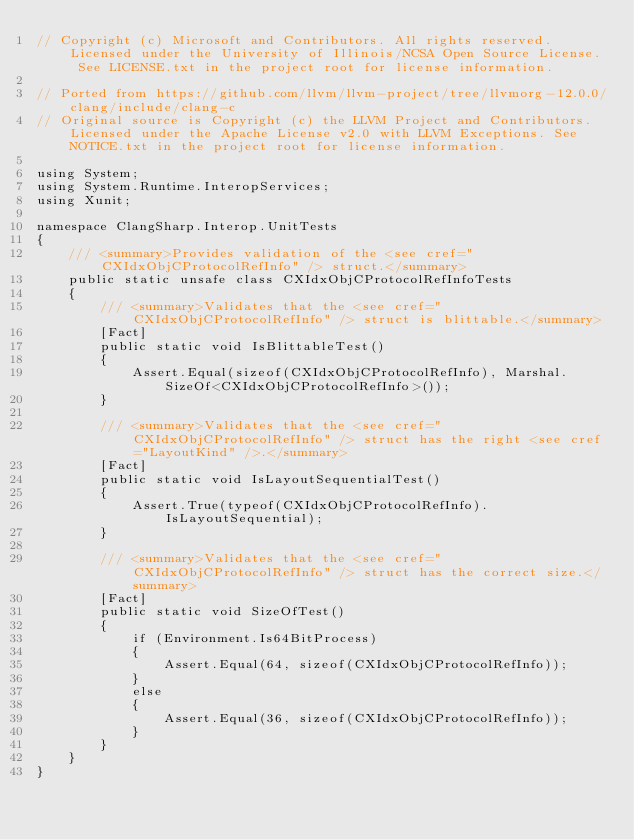<code> <loc_0><loc_0><loc_500><loc_500><_C#_>// Copyright (c) Microsoft and Contributors. All rights reserved. Licensed under the University of Illinois/NCSA Open Source License. See LICENSE.txt in the project root for license information.

// Ported from https://github.com/llvm/llvm-project/tree/llvmorg-12.0.0/clang/include/clang-c
// Original source is Copyright (c) the LLVM Project and Contributors. Licensed under the Apache License v2.0 with LLVM Exceptions. See NOTICE.txt in the project root for license information.

using System;
using System.Runtime.InteropServices;
using Xunit;

namespace ClangSharp.Interop.UnitTests
{
    /// <summary>Provides validation of the <see cref="CXIdxObjCProtocolRefInfo" /> struct.</summary>
    public static unsafe class CXIdxObjCProtocolRefInfoTests
    {
        /// <summary>Validates that the <see cref="CXIdxObjCProtocolRefInfo" /> struct is blittable.</summary>
        [Fact]
        public static void IsBlittableTest()
        {
            Assert.Equal(sizeof(CXIdxObjCProtocolRefInfo), Marshal.SizeOf<CXIdxObjCProtocolRefInfo>());
        }

        /// <summary>Validates that the <see cref="CXIdxObjCProtocolRefInfo" /> struct has the right <see cref="LayoutKind" />.</summary>
        [Fact]
        public static void IsLayoutSequentialTest()
        {
            Assert.True(typeof(CXIdxObjCProtocolRefInfo).IsLayoutSequential);
        }

        /// <summary>Validates that the <see cref="CXIdxObjCProtocolRefInfo" /> struct has the correct size.</summary>
        [Fact]
        public static void SizeOfTest()
        {
            if (Environment.Is64BitProcess)
            {
                Assert.Equal(64, sizeof(CXIdxObjCProtocolRefInfo));
            }
            else
            {
                Assert.Equal(36, sizeof(CXIdxObjCProtocolRefInfo));
            }
        }
    }
}
</code> 